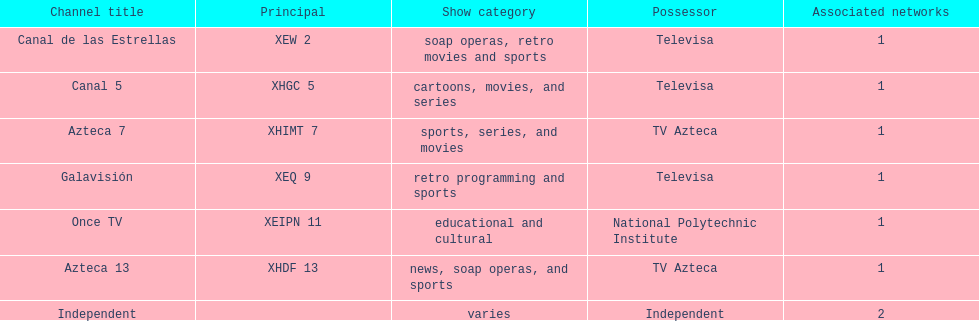Who is the only network owner listed in a consecutive order in the chart? Televisa. 